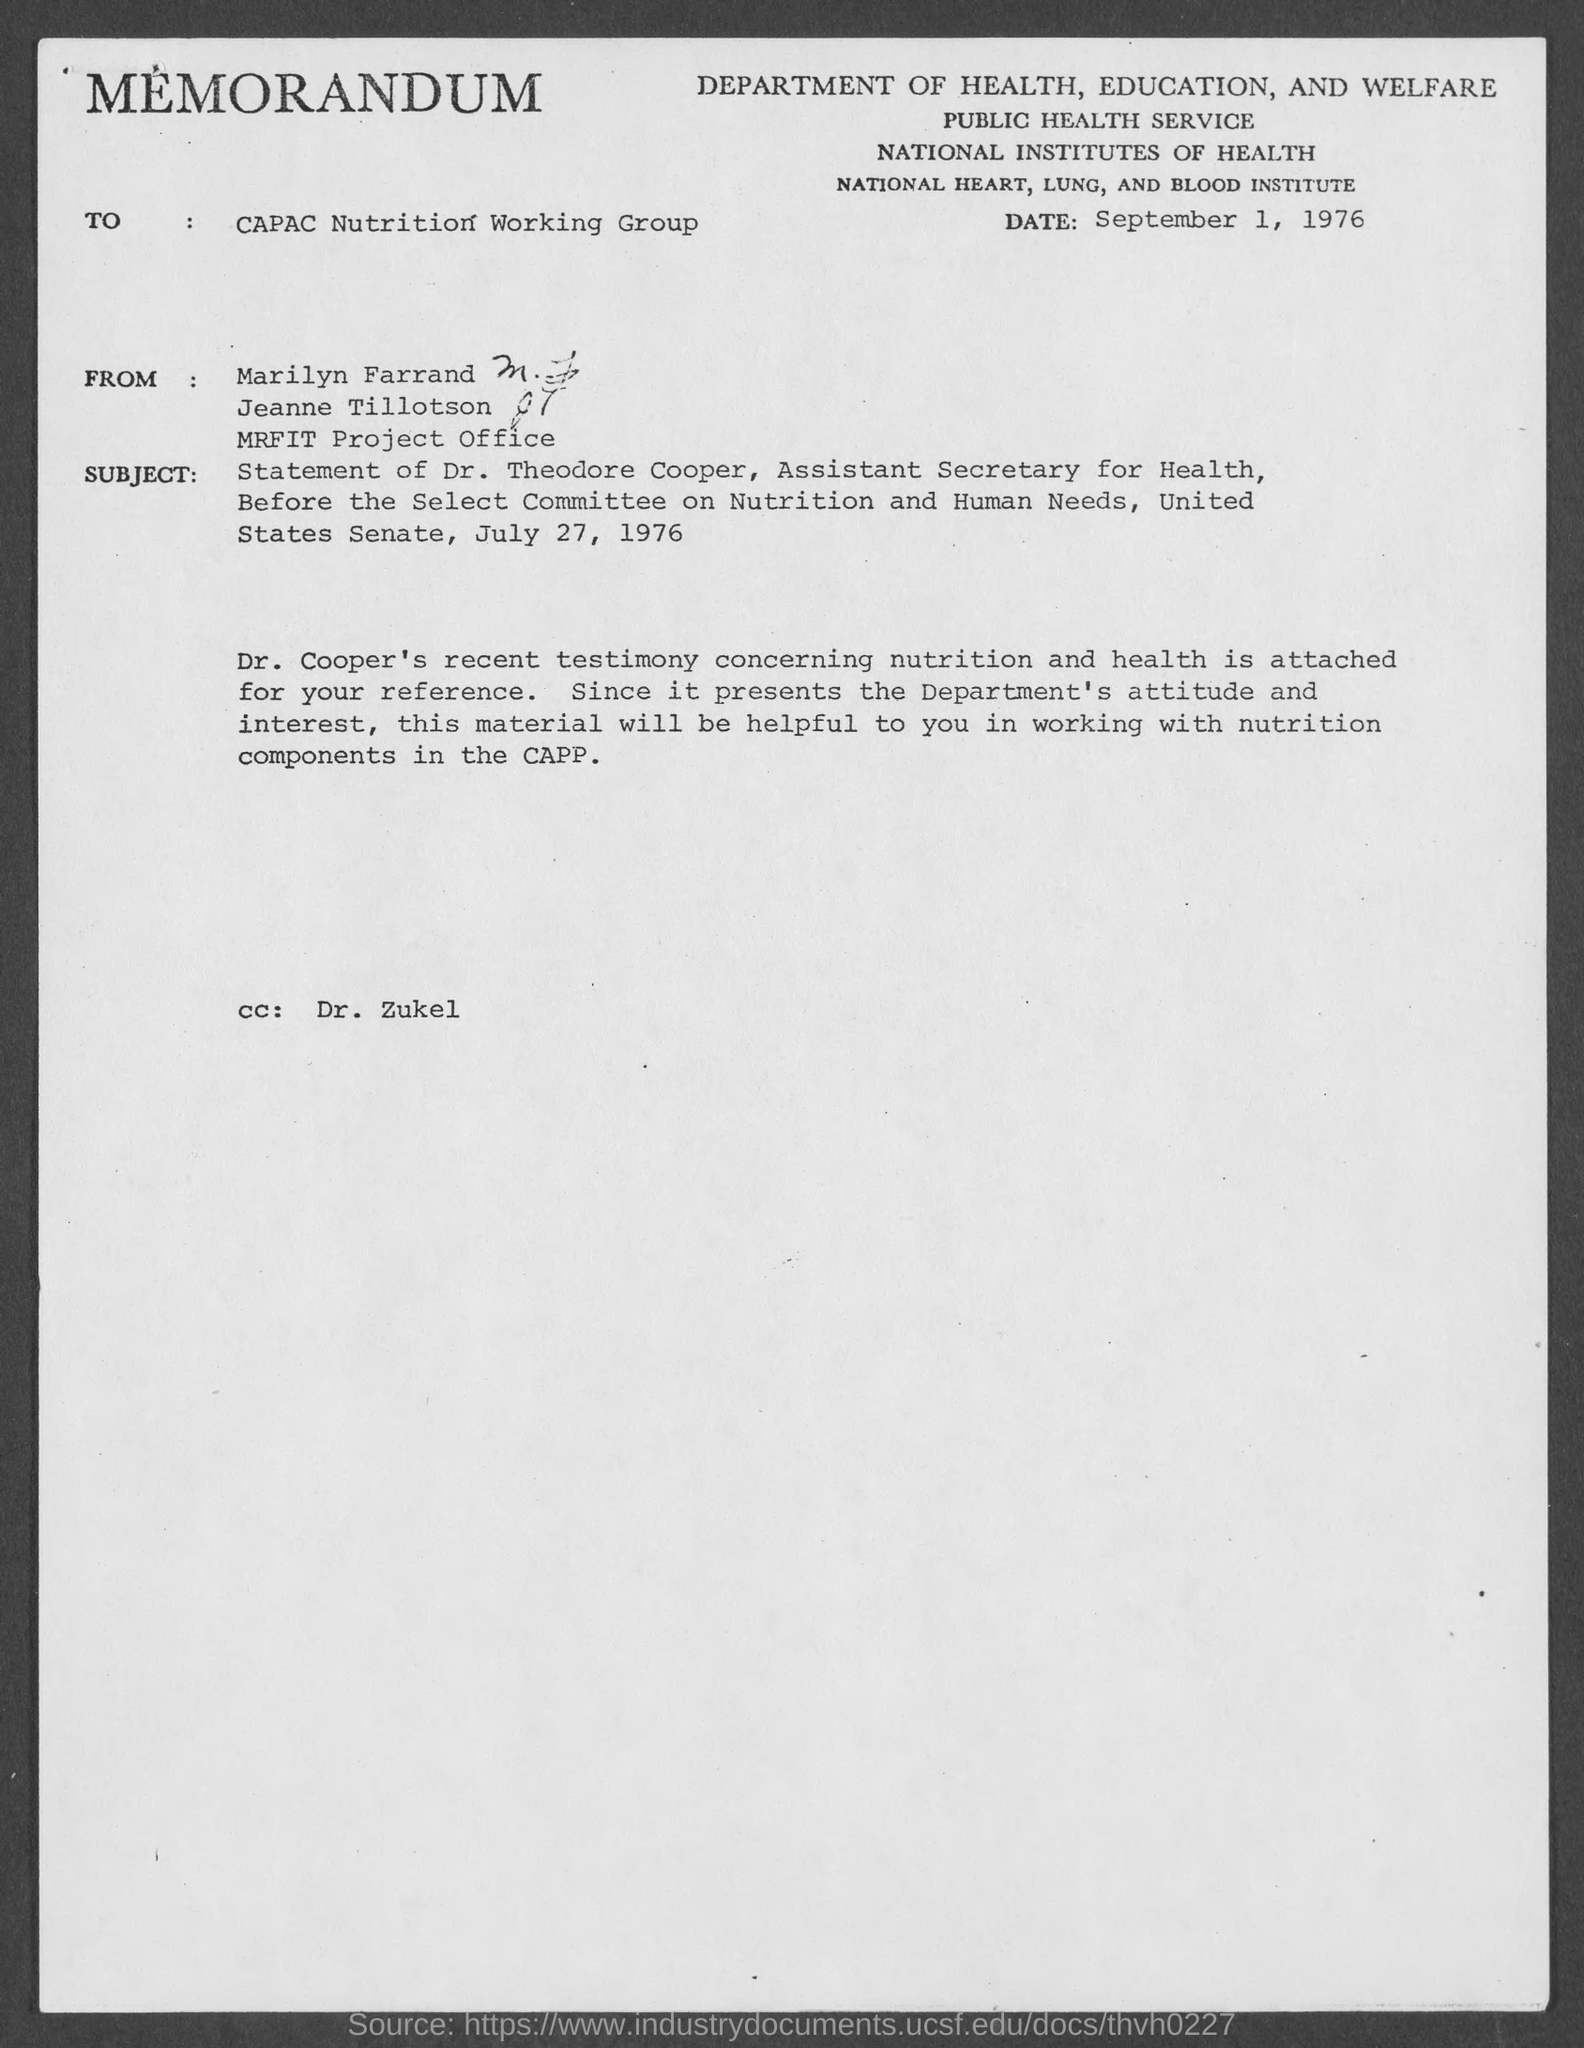Identify some key points in this picture. This is a memorandum, a type of communication. The recipient of this memorandum, DR. ZUKEL, has been marked. The memorandum is addressed to the CAPAC Nutrition Working Group. 